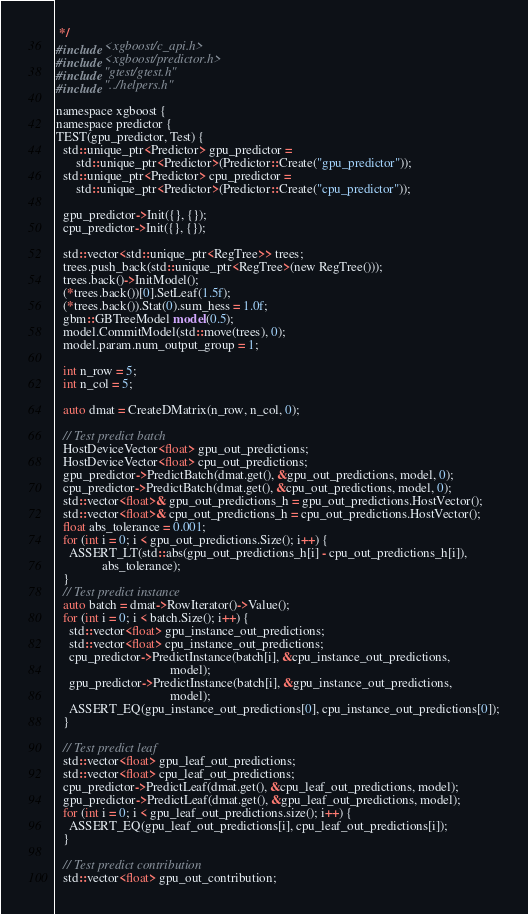<code> <loc_0><loc_0><loc_500><loc_500><_Cuda_> */
#include <xgboost/c_api.h>
#include <xgboost/predictor.h>
#include "gtest/gtest.h"
#include "../helpers.h"

namespace xgboost {
namespace predictor {
TEST(gpu_predictor, Test) {
  std::unique_ptr<Predictor> gpu_predictor =
      std::unique_ptr<Predictor>(Predictor::Create("gpu_predictor"));
  std::unique_ptr<Predictor> cpu_predictor =
      std::unique_ptr<Predictor>(Predictor::Create("cpu_predictor"));

  gpu_predictor->Init({}, {});
  cpu_predictor->Init({}, {});

  std::vector<std::unique_ptr<RegTree>> trees;
  trees.push_back(std::unique_ptr<RegTree>(new RegTree()));
  trees.back()->InitModel();
  (*trees.back())[0].SetLeaf(1.5f);
  (*trees.back()).Stat(0).sum_hess = 1.0f;
  gbm::GBTreeModel model(0.5);
  model.CommitModel(std::move(trees), 0);
  model.param.num_output_group = 1;

  int n_row = 5;
  int n_col = 5;

  auto dmat = CreateDMatrix(n_row, n_col, 0);

  // Test predict batch
  HostDeviceVector<float> gpu_out_predictions;
  HostDeviceVector<float> cpu_out_predictions;
  gpu_predictor->PredictBatch(dmat.get(), &gpu_out_predictions, model, 0);
  cpu_predictor->PredictBatch(dmat.get(), &cpu_out_predictions, model, 0);
  std::vector<float>& gpu_out_predictions_h = gpu_out_predictions.HostVector();
  std::vector<float>& cpu_out_predictions_h = cpu_out_predictions.HostVector();
  float abs_tolerance = 0.001;
  for (int i = 0; i < gpu_out_predictions.Size(); i++) {
    ASSERT_LT(std::abs(gpu_out_predictions_h[i] - cpu_out_predictions_h[i]),
              abs_tolerance);
  }
  // Test predict instance
  auto batch = dmat->RowIterator()->Value();
  for (int i = 0; i < batch.Size(); i++) {
    std::vector<float> gpu_instance_out_predictions;
    std::vector<float> cpu_instance_out_predictions;
    cpu_predictor->PredictInstance(batch[i], &cpu_instance_out_predictions,
                                   model);
    gpu_predictor->PredictInstance(batch[i], &gpu_instance_out_predictions,
                                   model);
    ASSERT_EQ(gpu_instance_out_predictions[0], cpu_instance_out_predictions[0]);
  }

  // Test predict leaf
  std::vector<float> gpu_leaf_out_predictions;
  std::vector<float> cpu_leaf_out_predictions;
  cpu_predictor->PredictLeaf(dmat.get(), &cpu_leaf_out_predictions, model);
  gpu_predictor->PredictLeaf(dmat.get(), &gpu_leaf_out_predictions, model);
  for (int i = 0; i < gpu_leaf_out_predictions.size(); i++) {
    ASSERT_EQ(gpu_leaf_out_predictions[i], cpu_leaf_out_predictions[i]);
  }

  // Test predict contribution
  std::vector<float> gpu_out_contribution;</code> 